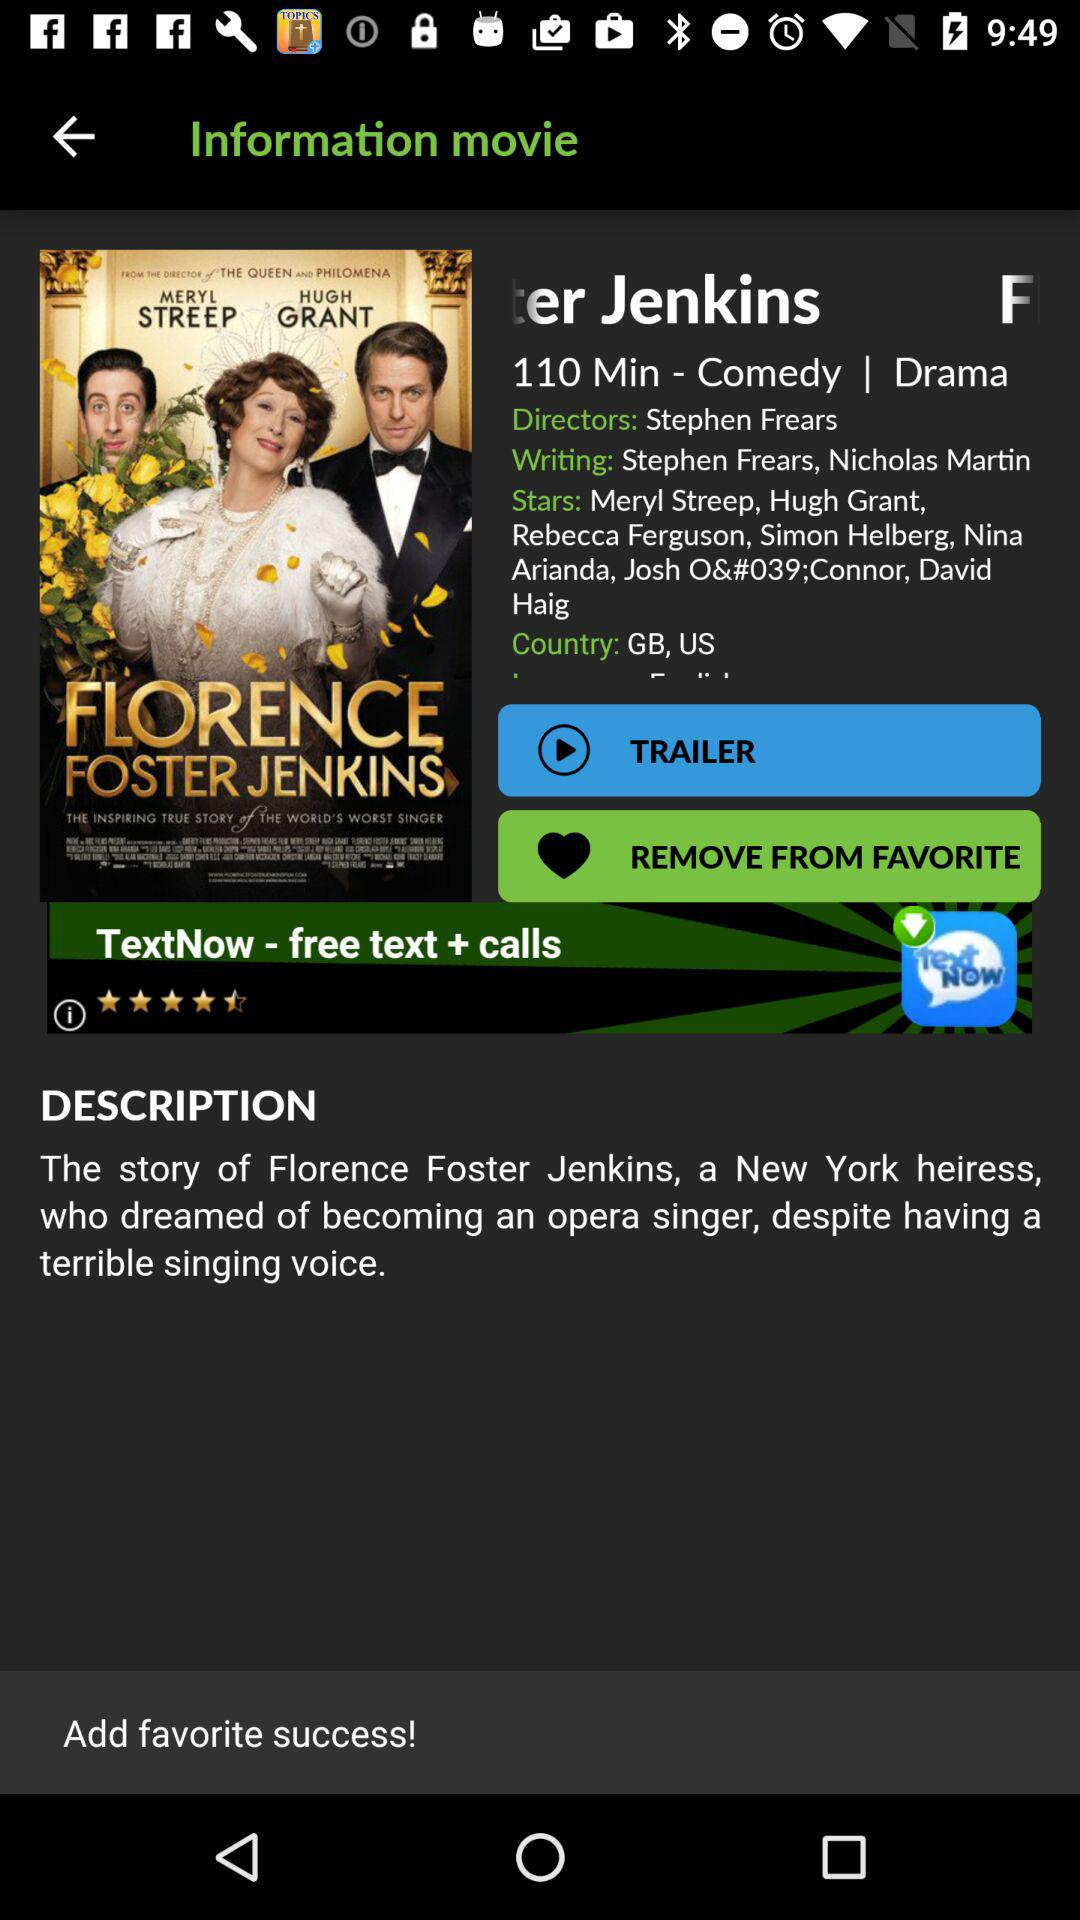In which country was the movie released? The movie was released in the United Kingdom and the United States. 